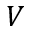Convert formula to latex. <formula><loc_0><loc_0><loc_500><loc_500>V</formula> 